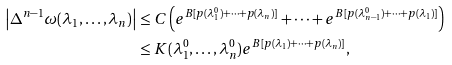Convert formula to latex. <formula><loc_0><loc_0><loc_500><loc_500>\left | \Delta ^ { n - 1 } \omega ( \lambda _ { 1 } , \dots , \lambda _ { n } ) \right | & \leq C \left ( e ^ { B [ p ( \lambda ^ { 0 } _ { 1 } ) + \cdots + p ( \lambda _ { n } ) ] } + \cdots + e ^ { B [ p ( \lambda ^ { 0 } _ { n - 1 } ) + \cdots + p ( \lambda _ { 1 } ) ] } \right ) \\ & \leq K ( \lambda ^ { 0 } _ { 1 } , \dots , \lambda ^ { 0 } _ { n } ) e ^ { B [ p ( \lambda _ { 1 } ) + \cdots + p ( \lambda _ { n } ) ] } ,</formula> 